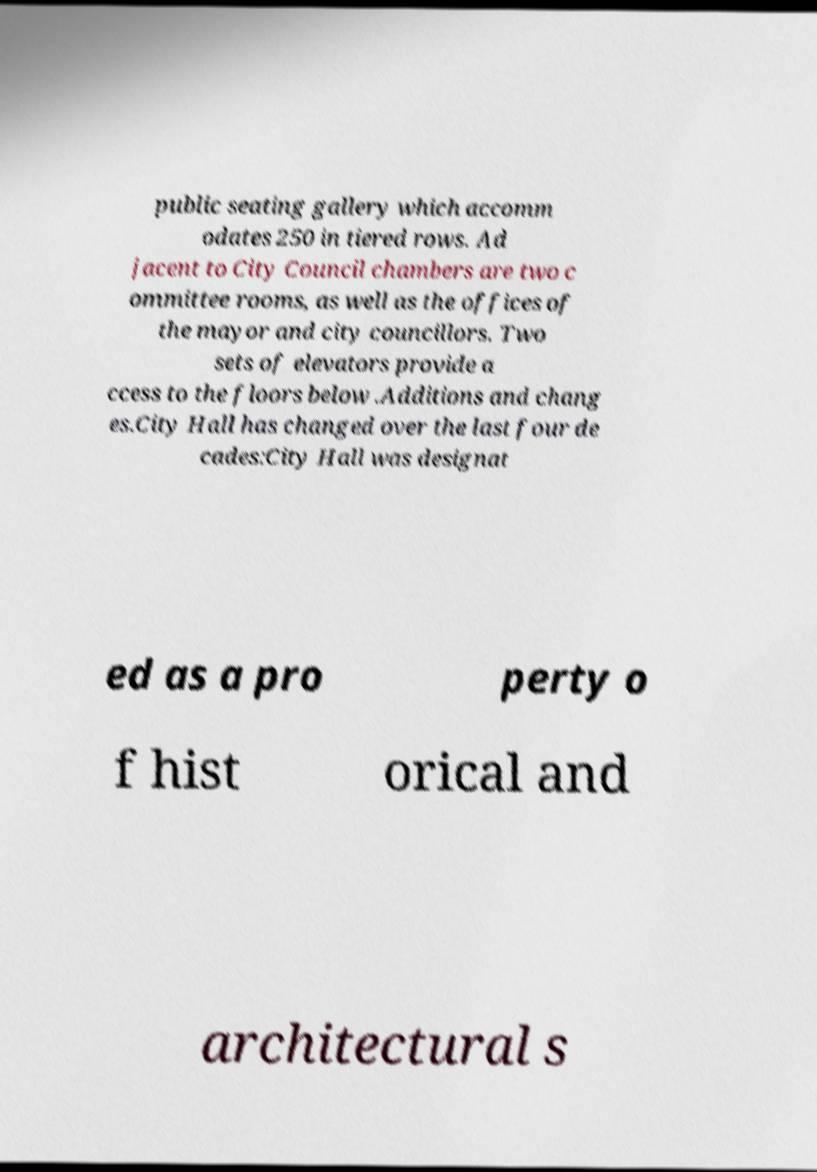There's text embedded in this image that I need extracted. Can you transcribe it verbatim? public seating gallery which accomm odates 250 in tiered rows. Ad jacent to City Council chambers are two c ommittee rooms, as well as the offices of the mayor and city councillors. Two sets of elevators provide a ccess to the floors below .Additions and chang es.City Hall has changed over the last four de cades:City Hall was designat ed as a pro perty o f hist orical and architectural s 